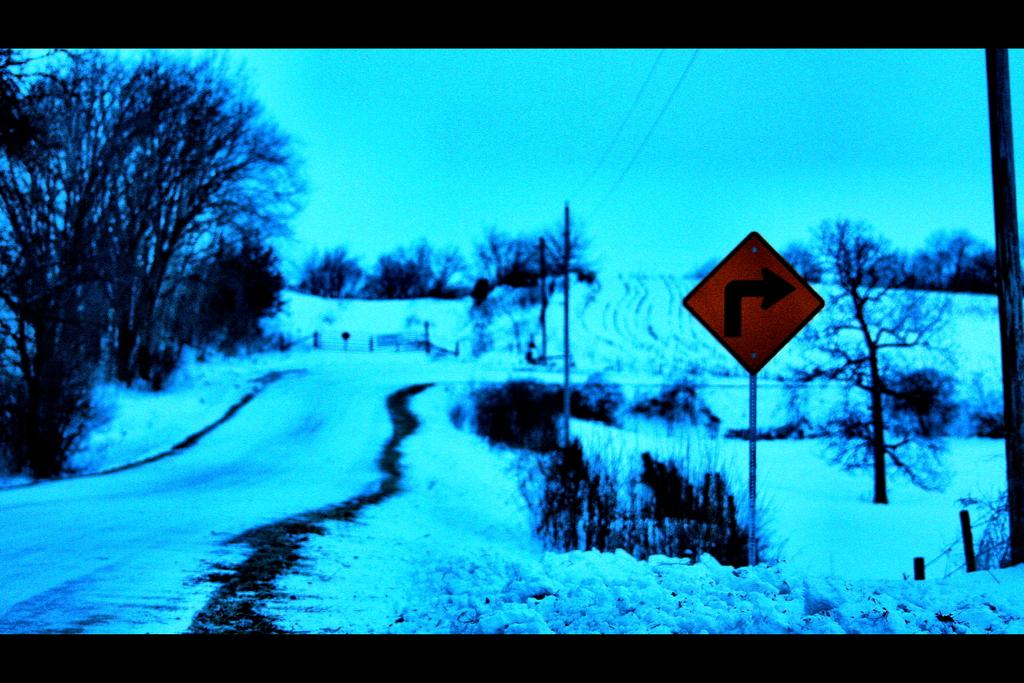What can be seen in the middle of the image? There are trees, signboards, poles, plants, and cables in the middle of the image. What is the natural element visible in the image? There are trees and plants in the middle of the image. What is the man-made element visible in the image? There are signboards and poles in the middle of the image. What is the condition of the sky in the image? The sky is visible in the image. Is there any ice visible in the image? Yes, there is ice visible in the image. Can you tell me how many rocks are depicted in the image? There are no rocks present in the image. What type of ball can be seen rolling on the ground in the image? There is no ball present in the image. 